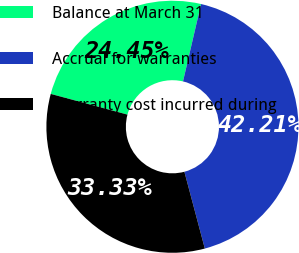Convert chart to OTSL. <chart><loc_0><loc_0><loc_500><loc_500><pie_chart><fcel>Balance at March 31<fcel>Accrual for warranties<fcel>Warranty cost incurred during<nl><fcel>24.45%<fcel>42.21%<fcel>33.33%<nl></chart> 